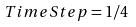<formula> <loc_0><loc_0><loc_500><loc_500>\ T i m e S t e p = 1 / 4</formula> 